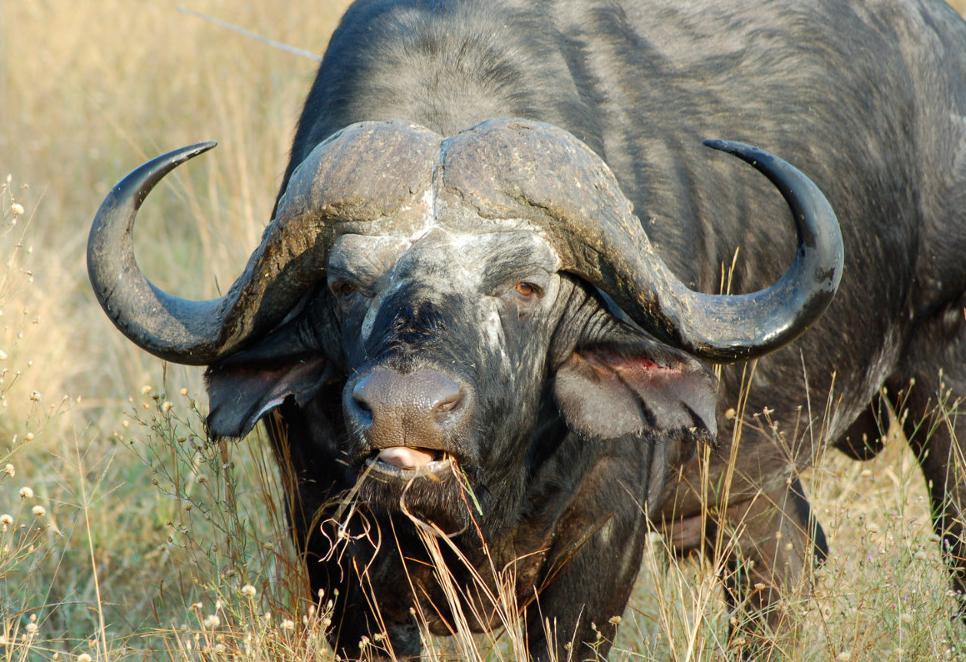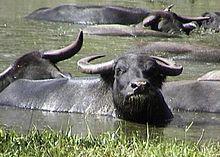The first image is the image on the left, the second image is the image on the right. For the images shown, is this caption "There are 2 wild cattle." true? Answer yes or no. No. 